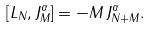Convert formula to latex. <formula><loc_0><loc_0><loc_500><loc_500>\left [ L _ { N } , J _ { M } ^ { \alpha } \right ] = - M \, J _ { N + M } ^ { \alpha } .</formula> 